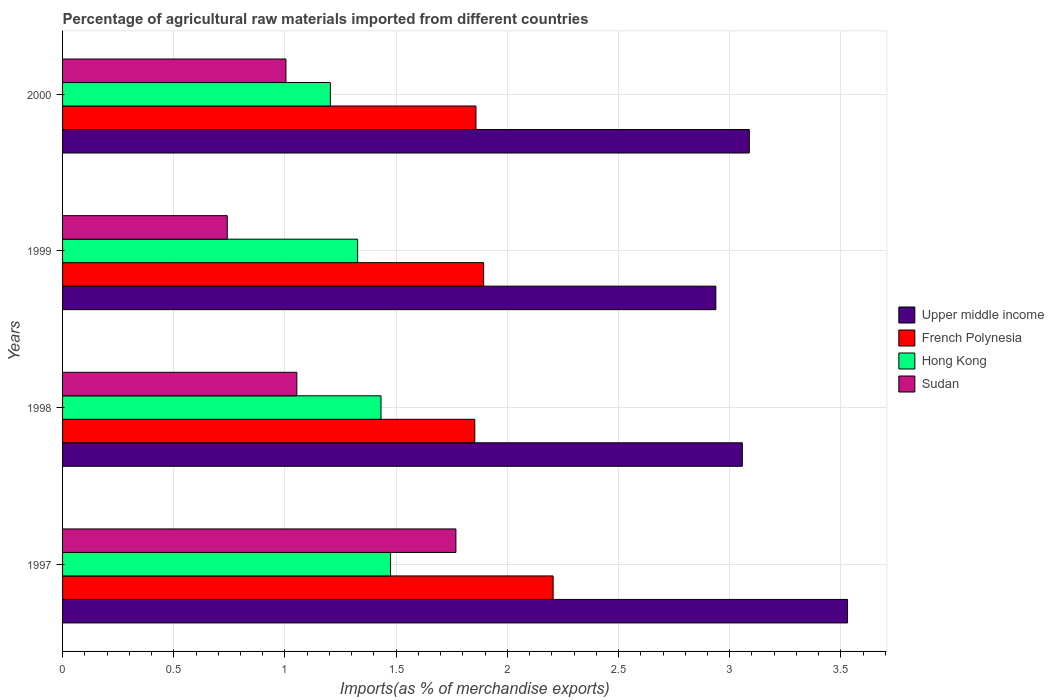How many groups of bars are there?
Ensure brevity in your answer.  4. Are the number of bars on each tick of the Y-axis equal?
Ensure brevity in your answer.  Yes. How many bars are there on the 2nd tick from the bottom?
Offer a terse response. 4. In how many cases, is the number of bars for a given year not equal to the number of legend labels?
Make the answer very short. 0. What is the percentage of imports to different countries in French Polynesia in 1999?
Keep it short and to the point. 1.89. Across all years, what is the maximum percentage of imports to different countries in Upper middle income?
Provide a short and direct response. 3.53. Across all years, what is the minimum percentage of imports to different countries in Upper middle income?
Your answer should be very brief. 2.94. What is the total percentage of imports to different countries in Hong Kong in the graph?
Provide a succinct answer. 5.44. What is the difference between the percentage of imports to different countries in Upper middle income in 1997 and that in 1999?
Offer a very short reply. 0.59. What is the difference between the percentage of imports to different countries in Upper middle income in 1997 and the percentage of imports to different countries in Sudan in 1998?
Give a very brief answer. 2.48. What is the average percentage of imports to different countries in Hong Kong per year?
Provide a succinct answer. 1.36. In the year 1997, what is the difference between the percentage of imports to different countries in Hong Kong and percentage of imports to different countries in Sudan?
Keep it short and to the point. -0.29. In how many years, is the percentage of imports to different countries in French Polynesia greater than 3.1 %?
Your response must be concise. 0. What is the ratio of the percentage of imports to different countries in Sudan in 1997 to that in 1998?
Give a very brief answer. 1.68. Is the percentage of imports to different countries in Hong Kong in 1998 less than that in 2000?
Ensure brevity in your answer.  No. Is the difference between the percentage of imports to different countries in Hong Kong in 1998 and 1999 greater than the difference between the percentage of imports to different countries in Sudan in 1998 and 1999?
Provide a short and direct response. No. What is the difference between the highest and the second highest percentage of imports to different countries in Upper middle income?
Provide a short and direct response. 0.44. What is the difference between the highest and the lowest percentage of imports to different countries in Sudan?
Make the answer very short. 1.03. In how many years, is the percentage of imports to different countries in Hong Kong greater than the average percentage of imports to different countries in Hong Kong taken over all years?
Your response must be concise. 2. Is the sum of the percentage of imports to different countries in French Polynesia in 1997 and 2000 greater than the maximum percentage of imports to different countries in Hong Kong across all years?
Provide a short and direct response. Yes. What does the 3rd bar from the top in 1997 represents?
Ensure brevity in your answer.  French Polynesia. What does the 3rd bar from the bottom in 1997 represents?
Your answer should be compact. Hong Kong. How many bars are there?
Offer a terse response. 16. Are all the bars in the graph horizontal?
Offer a very short reply. Yes. How many years are there in the graph?
Offer a terse response. 4. Are the values on the major ticks of X-axis written in scientific E-notation?
Your response must be concise. No. Where does the legend appear in the graph?
Provide a succinct answer. Center right. What is the title of the graph?
Ensure brevity in your answer.  Percentage of agricultural raw materials imported from different countries. What is the label or title of the X-axis?
Make the answer very short. Imports(as % of merchandise exports). What is the label or title of the Y-axis?
Keep it short and to the point. Years. What is the Imports(as % of merchandise exports) of Upper middle income in 1997?
Your answer should be compact. 3.53. What is the Imports(as % of merchandise exports) of French Polynesia in 1997?
Your response must be concise. 2.21. What is the Imports(as % of merchandise exports) of Hong Kong in 1997?
Your answer should be very brief. 1.47. What is the Imports(as % of merchandise exports) in Sudan in 1997?
Your answer should be very brief. 1.77. What is the Imports(as % of merchandise exports) of Upper middle income in 1998?
Keep it short and to the point. 3.06. What is the Imports(as % of merchandise exports) in French Polynesia in 1998?
Your answer should be compact. 1.85. What is the Imports(as % of merchandise exports) in Hong Kong in 1998?
Provide a short and direct response. 1.43. What is the Imports(as % of merchandise exports) of Sudan in 1998?
Your answer should be compact. 1.05. What is the Imports(as % of merchandise exports) of Upper middle income in 1999?
Keep it short and to the point. 2.94. What is the Imports(as % of merchandise exports) of French Polynesia in 1999?
Provide a succinct answer. 1.89. What is the Imports(as % of merchandise exports) of Hong Kong in 1999?
Provide a succinct answer. 1.33. What is the Imports(as % of merchandise exports) in Sudan in 1999?
Ensure brevity in your answer.  0.74. What is the Imports(as % of merchandise exports) in Upper middle income in 2000?
Make the answer very short. 3.09. What is the Imports(as % of merchandise exports) in French Polynesia in 2000?
Keep it short and to the point. 1.86. What is the Imports(as % of merchandise exports) of Hong Kong in 2000?
Your answer should be very brief. 1.2. What is the Imports(as % of merchandise exports) of Sudan in 2000?
Your answer should be compact. 1. Across all years, what is the maximum Imports(as % of merchandise exports) of Upper middle income?
Keep it short and to the point. 3.53. Across all years, what is the maximum Imports(as % of merchandise exports) in French Polynesia?
Offer a very short reply. 2.21. Across all years, what is the maximum Imports(as % of merchandise exports) in Hong Kong?
Give a very brief answer. 1.47. Across all years, what is the maximum Imports(as % of merchandise exports) of Sudan?
Provide a short and direct response. 1.77. Across all years, what is the minimum Imports(as % of merchandise exports) of Upper middle income?
Your response must be concise. 2.94. Across all years, what is the minimum Imports(as % of merchandise exports) of French Polynesia?
Ensure brevity in your answer.  1.85. Across all years, what is the minimum Imports(as % of merchandise exports) in Hong Kong?
Make the answer very short. 1.2. Across all years, what is the minimum Imports(as % of merchandise exports) in Sudan?
Keep it short and to the point. 0.74. What is the total Imports(as % of merchandise exports) in Upper middle income in the graph?
Keep it short and to the point. 12.61. What is the total Imports(as % of merchandise exports) in French Polynesia in the graph?
Provide a short and direct response. 7.81. What is the total Imports(as % of merchandise exports) of Hong Kong in the graph?
Keep it short and to the point. 5.44. What is the total Imports(as % of merchandise exports) of Sudan in the graph?
Keep it short and to the point. 4.57. What is the difference between the Imports(as % of merchandise exports) of Upper middle income in 1997 and that in 1998?
Offer a terse response. 0.47. What is the difference between the Imports(as % of merchandise exports) in French Polynesia in 1997 and that in 1998?
Keep it short and to the point. 0.35. What is the difference between the Imports(as % of merchandise exports) of Hong Kong in 1997 and that in 1998?
Offer a very short reply. 0.04. What is the difference between the Imports(as % of merchandise exports) in Sudan in 1997 and that in 1998?
Provide a succinct answer. 0.72. What is the difference between the Imports(as % of merchandise exports) in Upper middle income in 1997 and that in 1999?
Give a very brief answer. 0.59. What is the difference between the Imports(as % of merchandise exports) in French Polynesia in 1997 and that in 1999?
Ensure brevity in your answer.  0.31. What is the difference between the Imports(as % of merchandise exports) in Hong Kong in 1997 and that in 1999?
Make the answer very short. 0.15. What is the difference between the Imports(as % of merchandise exports) of Sudan in 1997 and that in 1999?
Your answer should be compact. 1.03. What is the difference between the Imports(as % of merchandise exports) in Upper middle income in 1997 and that in 2000?
Your response must be concise. 0.44. What is the difference between the Imports(as % of merchandise exports) in French Polynesia in 1997 and that in 2000?
Provide a short and direct response. 0.35. What is the difference between the Imports(as % of merchandise exports) of Hong Kong in 1997 and that in 2000?
Your answer should be compact. 0.27. What is the difference between the Imports(as % of merchandise exports) of Sudan in 1997 and that in 2000?
Provide a short and direct response. 0.76. What is the difference between the Imports(as % of merchandise exports) of Upper middle income in 1998 and that in 1999?
Ensure brevity in your answer.  0.12. What is the difference between the Imports(as % of merchandise exports) in French Polynesia in 1998 and that in 1999?
Provide a short and direct response. -0.04. What is the difference between the Imports(as % of merchandise exports) in Hong Kong in 1998 and that in 1999?
Your answer should be very brief. 0.11. What is the difference between the Imports(as % of merchandise exports) of Sudan in 1998 and that in 1999?
Your answer should be very brief. 0.31. What is the difference between the Imports(as % of merchandise exports) in Upper middle income in 1998 and that in 2000?
Provide a short and direct response. -0.03. What is the difference between the Imports(as % of merchandise exports) of French Polynesia in 1998 and that in 2000?
Your answer should be very brief. -0.01. What is the difference between the Imports(as % of merchandise exports) in Hong Kong in 1998 and that in 2000?
Offer a terse response. 0.23. What is the difference between the Imports(as % of merchandise exports) in Sudan in 1998 and that in 2000?
Offer a very short reply. 0.05. What is the difference between the Imports(as % of merchandise exports) of Upper middle income in 1999 and that in 2000?
Your answer should be compact. -0.15. What is the difference between the Imports(as % of merchandise exports) of French Polynesia in 1999 and that in 2000?
Your answer should be compact. 0.03. What is the difference between the Imports(as % of merchandise exports) of Hong Kong in 1999 and that in 2000?
Your answer should be compact. 0.12. What is the difference between the Imports(as % of merchandise exports) of Sudan in 1999 and that in 2000?
Make the answer very short. -0.26. What is the difference between the Imports(as % of merchandise exports) of Upper middle income in 1997 and the Imports(as % of merchandise exports) of French Polynesia in 1998?
Provide a short and direct response. 1.68. What is the difference between the Imports(as % of merchandise exports) of Upper middle income in 1997 and the Imports(as % of merchandise exports) of Hong Kong in 1998?
Your answer should be compact. 2.1. What is the difference between the Imports(as % of merchandise exports) in Upper middle income in 1997 and the Imports(as % of merchandise exports) in Sudan in 1998?
Provide a short and direct response. 2.48. What is the difference between the Imports(as % of merchandise exports) in French Polynesia in 1997 and the Imports(as % of merchandise exports) in Hong Kong in 1998?
Provide a succinct answer. 0.77. What is the difference between the Imports(as % of merchandise exports) in French Polynesia in 1997 and the Imports(as % of merchandise exports) in Sudan in 1998?
Give a very brief answer. 1.15. What is the difference between the Imports(as % of merchandise exports) of Hong Kong in 1997 and the Imports(as % of merchandise exports) of Sudan in 1998?
Your response must be concise. 0.42. What is the difference between the Imports(as % of merchandise exports) of Upper middle income in 1997 and the Imports(as % of merchandise exports) of French Polynesia in 1999?
Give a very brief answer. 1.64. What is the difference between the Imports(as % of merchandise exports) of Upper middle income in 1997 and the Imports(as % of merchandise exports) of Hong Kong in 1999?
Provide a succinct answer. 2.2. What is the difference between the Imports(as % of merchandise exports) of Upper middle income in 1997 and the Imports(as % of merchandise exports) of Sudan in 1999?
Your answer should be compact. 2.79. What is the difference between the Imports(as % of merchandise exports) of French Polynesia in 1997 and the Imports(as % of merchandise exports) of Hong Kong in 1999?
Provide a short and direct response. 0.88. What is the difference between the Imports(as % of merchandise exports) in French Polynesia in 1997 and the Imports(as % of merchandise exports) in Sudan in 1999?
Keep it short and to the point. 1.47. What is the difference between the Imports(as % of merchandise exports) in Hong Kong in 1997 and the Imports(as % of merchandise exports) in Sudan in 1999?
Your answer should be compact. 0.73. What is the difference between the Imports(as % of merchandise exports) of Upper middle income in 1997 and the Imports(as % of merchandise exports) of French Polynesia in 2000?
Your response must be concise. 1.67. What is the difference between the Imports(as % of merchandise exports) in Upper middle income in 1997 and the Imports(as % of merchandise exports) in Hong Kong in 2000?
Keep it short and to the point. 2.33. What is the difference between the Imports(as % of merchandise exports) of Upper middle income in 1997 and the Imports(as % of merchandise exports) of Sudan in 2000?
Ensure brevity in your answer.  2.53. What is the difference between the Imports(as % of merchandise exports) of French Polynesia in 1997 and the Imports(as % of merchandise exports) of Sudan in 2000?
Your answer should be compact. 1.2. What is the difference between the Imports(as % of merchandise exports) in Hong Kong in 1997 and the Imports(as % of merchandise exports) in Sudan in 2000?
Offer a very short reply. 0.47. What is the difference between the Imports(as % of merchandise exports) of Upper middle income in 1998 and the Imports(as % of merchandise exports) of French Polynesia in 1999?
Provide a succinct answer. 1.16. What is the difference between the Imports(as % of merchandise exports) in Upper middle income in 1998 and the Imports(as % of merchandise exports) in Hong Kong in 1999?
Your answer should be very brief. 1.73. What is the difference between the Imports(as % of merchandise exports) of Upper middle income in 1998 and the Imports(as % of merchandise exports) of Sudan in 1999?
Ensure brevity in your answer.  2.32. What is the difference between the Imports(as % of merchandise exports) in French Polynesia in 1998 and the Imports(as % of merchandise exports) in Hong Kong in 1999?
Offer a very short reply. 0.53. What is the difference between the Imports(as % of merchandise exports) of French Polynesia in 1998 and the Imports(as % of merchandise exports) of Sudan in 1999?
Your answer should be very brief. 1.11. What is the difference between the Imports(as % of merchandise exports) in Hong Kong in 1998 and the Imports(as % of merchandise exports) in Sudan in 1999?
Ensure brevity in your answer.  0.69. What is the difference between the Imports(as % of merchandise exports) of Upper middle income in 1998 and the Imports(as % of merchandise exports) of French Polynesia in 2000?
Make the answer very short. 1.2. What is the difference between the Imports(as % of merchandise exports) of Upper middle income in 1998 and the Imports(as % of merchandise exports) of Hong Kong in 2000?
Provide a short and direct response. 1.85. What is the difference between the Imports(as % of merchandise exports) of Upper middle income in 1998 and the Imports(as % of merchandise exports) of Sudan in 2000?
Keep it short and to the point. 2.05. What is the difference between the Imports(as % of merchandise exports) of French Polynesia in 1998 and the Imports(as % of merchandise exports) of Hong Kong in 2000?
Your answer should be very brief. 0.65. What is the difference between the Imports(as % of merchandise exports) of French Polynesia in 1998 and the Imports(as % of merchandise exports) of Sudan in 2000?
Your answer should be compact. 0.85. What is the difference between the Imports(as % of merchandise exports) of Hong Kong in 1998 and the Imports(as % of merchandise exports) of Sudan in 2000?
Ensure brevity in your answer.  0.43. What is the difference between the Imports(as % of merchandise exports) in Upper middle income in 1999 and the Imports(as % of merchandise exports) in French Polynesia in 2000?
Ensure brevity in your answer.  1.08. What is the difference between the Imports(as % of merchandise exports) of Upper middle income in 1999 and the Imports(as % of merchandise exports) of Hong Kong in 2000?
Make the answer very short. 1.73. What is the difference between the Imports(as % of merchandise exports) in Upper middle income in 1999 and the Imports(as % of merchandise exports) in Sudan in 2000?
Offer a very short reply. 1.93. What is the difference between the Imports(as % of merchandise exports) of French Polynesia in 1999 and the Imports(as % of merchandise exports) of Hong Kong in 2000?
Offer a terse response. 0.69. What is the difference between the Imports(as % of merchandise exports) in French Polynesia in 1999 and the Imports(as % of merchandise exports) in Sudan in 2000?
Give a very brief answer. 0.89. What is the difference between the Imports(as % of merchandise exports) of Hong Kong in 1999 and the Imports(as % of merchandise exports) of Sudan in 2000?
Your response must be concise. 0.32. What is the average Imports(as % of merchandise exports) of Upper middle income per year?
Keep it short and to the point. 3.15. What is the average Imports(as % of merchandise exports) in French Polynesia per year?
Provide a succinct answer. 1.95. What is the average Imports(as % of merchandise exports) in Hong Kong per year?
Give a very brief answer. 1.36. What is the average Imports(as % of merchandise exports) in Sudan per year?
Your answer should be compact. 1.14. In the year 1997, what is the difference between the Imports(as % of merchandise exports) of Upper middle income and Imports(as % of merchandise exports) of French Polynesia?
Ensure brevity in your answer.  1.32. In the year 1997, what is the difference between the Imports(as % of merchandise exports) in Upper middle income and Imports(as % of merchandise exports) in Hong Kong?
Your answer should be compact. 2.06. In the year 1997, what is the difference between the Imports(as % of merchandise exports) of Upper middle income and Imports(as % of merchandise exports) of Sudan?
Keep it short and to the point. 1.76. In the year 1997, what is the difference between the Imports(as % of merchandise exports) of French Polynesia and Imports(as % of merchandise exports) of Hong Kong?
Ensure brevity in your answer.  0.73. In the year 1997, what is the difference between the Imports(as % of merchandise exports) in French Polynesia and Imports(as % of merchandise exports) in Sudan?
Your answer should be compact. 0.44. In the year 1997, what is the difference between the Imports(as % of merchandise exports) of Hong Kong and Imports(as % of merchandise exports) of Sudan?
Your answer should be very brief. -0.29. In the year 1998, what is the difference between the Imports(as % of merchandise exports) of Upper middle income and Imports(as % of merchandise exports) of French Polynesia?
Keep it short and to the point. 1.2. In the year 1998, what is the difference between the Imports(as % of merchandise exports) of Upper middle income and Imports(as % of merchandise exports) of Hong Kong?
Offer a very short reply. 1.62. In the year 1998, what is the difference between the Imports(as % of merchandise exports) of Upper middle income and Imports(as % of merchandise exports) of Sudan?
Provide a succinct answer. 2. In the year 1998, what is the difference between the Imports(as % of merchandise exports) of French Polynesia and Imports(as % of merchandise exports) of Hong Kong?
Keep it short and to the point. 0.42. In the year 1998, what is the difference between the Imports(as % of merchandise exports) in French Polynesia and Imports(as % of merchandise exports) in Sudan?
Keep it short and to the point. 0.8. In the year 1998, what is the difference between the Imports(as % of merchandise exports) of Hong Kong and Imports(as % of merchandise exports) of Sudan?
Your response must be concise. 0.38. In the year 1999, what is the difference between the Imports(as % of merchandise exports) of Upper middle income and Imports(as % of merchandise exports) of French Polynesia?
Make the answer very short. 1.04. In the year 1999, what is the difference between the Imports(as % of merchandise exports) of Upper middle income and Imports(as % of merchandise exports) of Hong Kong?
Provide a succinct answer. 1.61. In the year 1999, what is the difference between the Imports(as % of merchandise exports) of Upper middle income and Imports(as % of merchandise exports) of Sudan?
Your answer should be compact. 2.2. In the year 1999, what is the difference between the Imports(as % of merchandise exports) of French Polynesia and Imports(as % of merchandise exports) of Hong Kong?
Your response must be concise. 0.57. In the year 1999, what is the difference between the Imports(as % of merchandise exports) of French Polynesia and Imports(as % of merchandise exports) of Sudan?
Your answer should be compact. 1.15. In the year 1999, what is the difference between the Imports(as % of merchandise exports) of Hong Kong and Imports(as % of merchandise exports) of Sudan?
Make the answer very short. 0.59. In the year 2000, what is the difference between the Imports(as % of merchandise exports) of Upper middle income and Imports(as % of merchandise exports) of French Polynesia?
Offer a very short reply. 1.23. In the year 2000, what is the difference between the Imports(as % of merchandise exports) of Upper middle income and Imports(as % of merchandise exports) of Hong Kong?
Provide a succinct answer. 1.88. In the year 2000, what is the difference between the Imports(as % of merchandise exports) of Upper middle income and Imports(as % of merchandise exports) of Sudan?
Your response must be concise. 2.08. In the year 2000, what is the difference between the Imports(as % of merchandise exports) of French Polynesia and Imports(as % of merchandise exports) of Hong Kong?
Your response must be concise. 0.65. In the year 2000, what is the difference between the Imports(as % of merchandise exports) in French Polynesia and Imports(as % of merchandise exports) in Sudan?
Give a very brief answer. 0.85. In the year 2000, what is the difference between the Imports(as % of merchandise exports) in Hong Kong and Imports(as % of merchandise exports) in Sudan?
Ensure brevity in your answer.  0.2. What is the ratio of the Imports(as % of merchandise exports) of Upper middle income in 1997 to that in 1998?
Ensure brevity in your answer.  1.15. What is the ratio of the Imports(as % of merchandise exports) in French Polynesia in 1997 to that in 1998?
Provide a short and direct response. 1.19. What is the ratio of the Imports(as % of merchandise exports) of Sudan in 1997 to that in 1998?
Provide a short and direct response. 1.68. What is the ratio of the Imports(as % of merchandise exports) in Upper middle income in 1997 to that in 1999?
Your answer should be compact. 1.2. What is the ratio of the Imports(as % of merchandise exports) in French Polynesia in 1997 to that in 1999?
Offer a terse response. 1.17. What is the ratio of the Imports(as % of merchandise exports) of Hong Kong in 1997 to that in 1999?
Give a very brief answer. 1.11. What is the ratio of the Imports(as % of merchandise exports) in Sudan in 1997 to that in 1999?
Your answer should be compact. 2.39. What is the ratio of the Imports(as % of merchandise exports) of Upper middle income in 1997 to that in 2000?
Provide a succinct answer. 1.14. What is the ratio of the Imports(as % of merchandise exports) of French Polynesia in 1997 to that in 2000?
Provide a short and direct response. 1.19. What is the ratio of the Imports(as % of merchandise exports) of Hong Kong in 1997 to that in 2000?
Offer a very short reply. 1.22. What is the ratio of the Imports(as % of merchandise exports) in Sudan in 1997 to that in 2000?
Give a very brief answer. 1.76. What is the ratio of the Imports(as % of merchandise exports) of Upper middle income in 1998 to that in 1999?
Give a very brief answer. 1.04. What is the ratio of the Imports(as % of merchandise exports) of French Polynesia in 1998 to that in 1999?
Your answer should be very brief. 0.98. What is the ratio of the Imports(as % of merchandise exports) in Hong Kong in 1998 to that in 1999?
Your answer should be compact. 1.08. What is the ratio of the Imports(as % of merchandise exports) in Sudan in 1998 to that in 1999?
Make the answer very short. 1.42. What is the ratio of the Imports(as % of merchandise exports) of Upper middle income in 1998 to that in 2000?
Keep it short and to the point. 0.99. What is the ratio of the Imports(as % of merchandise exports) in French Polynesia in 1998 to that in 2000?
Provide a short and direct response. 1. What is the ratio of the Imports(as % of merchandise exports) of Hong Kong in 1998 to that in 2000?
Keep it short and to the point. 1.19. What is the ratio of the Imports(as % of merchandise exports) in Sudan in 1998 to that in 2000?
Your answer should be compact. 1.05. What is the ratio of the Imports(as % of merchandise exports) of Upper middle income in 1999 to that in 2000?
Provide a succinct answer. 0.95. What is the ratio of the Imports(as % of merchandise exports) of French Polynesia in 1999 to that in 2000?
Provide a succinct answer. 1.02. What is the ratio of the Imports(as % of merchandise exports) in Hong Kong in 1999 to that in 2000?
Your answer should be very brief. 1.1. What is the ratio of the Imports(as % of merchandise exports) of Sudan in 1999 to that in 2000?
Give a very brief answer. 0.74. What is the difference between the highest and the second highest Imports(as % of merchandise exports) in Upper middle income?
Keep it short and to the point. 0.44. What is the difference between the highest and the second highest Imports(as % of merchandise exports) of French Polynesia?
Your answer should be compact. 0.31. What is the difference between the highest and the second highest Imports(as % of merchandise exports) of Hong Kong?
Offer a very short reply. 0.04. What is the difference between the highest and the second highest Imports(as % of merchandise exports) in Sudan?
Make the answer very short. 0.72. What is the difference between the highest and the lowest Imports(as % of merchandise exports) in Upper middle income?
Your response must be concise. 0.59. What is the difference between the highest and the lowest Imports(as % of merchandise exports) in French Polynesia?
Your answer should be compact. 0.35. What is the difference between the highest and the lowest Imports(as % of merchandise exports) in Hong Kong?
Keep it short and to the point. 0.27. What is the difference between the highest and the lowest Imports(as % of merchandise exports) of Sudan?
Give a very brief answer. 1.03. 